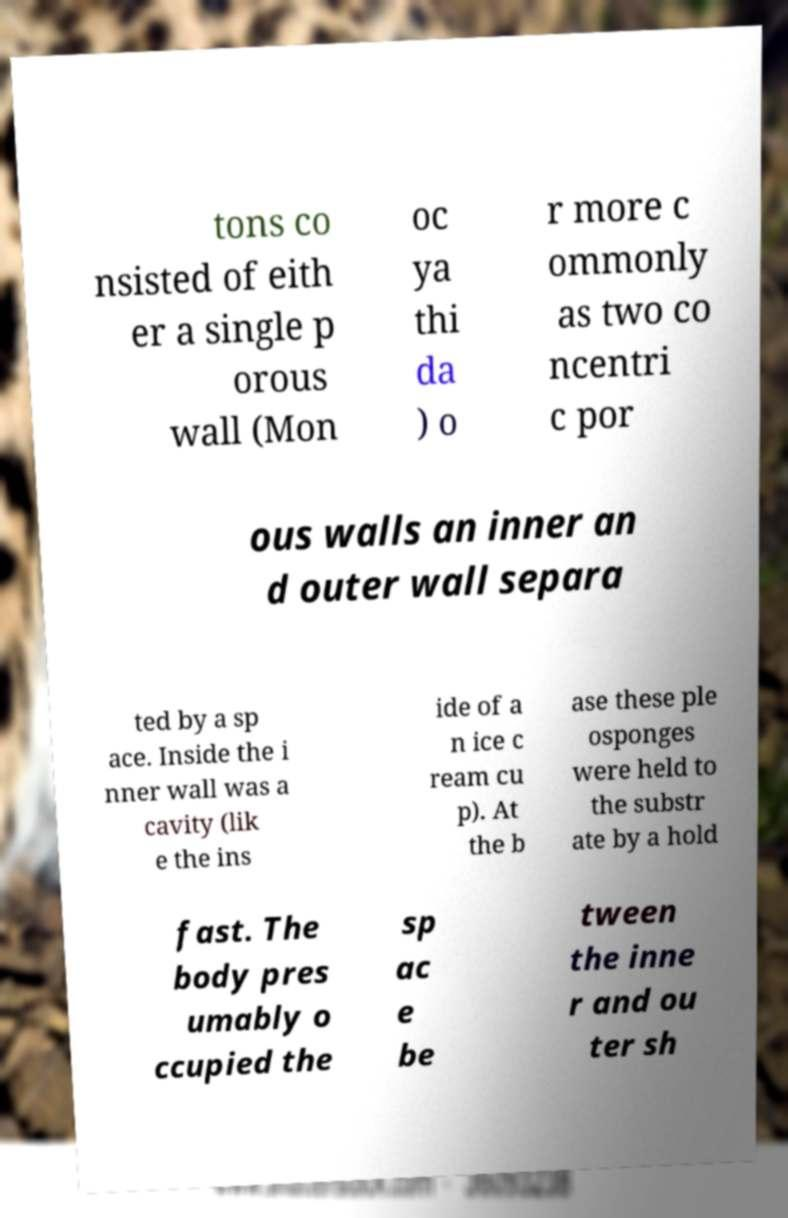Please read and relay the text visible in this image. What does it say? tons co nsisted of eith er a single p orous wall (Mon oc ya thi da ) o r more c ommonly as two co ncentri c por ous walls an inner an d outer wall separa ted by a sp ace. Inside the i nner wall was a cavity (lik e the ins ide of a n ice c ream cu p). At the b ase these ple osponges were held to the substr ate by a hold fast. The body pres umably o ccupied the sp ac e be tween the inne r and ou ter sh 